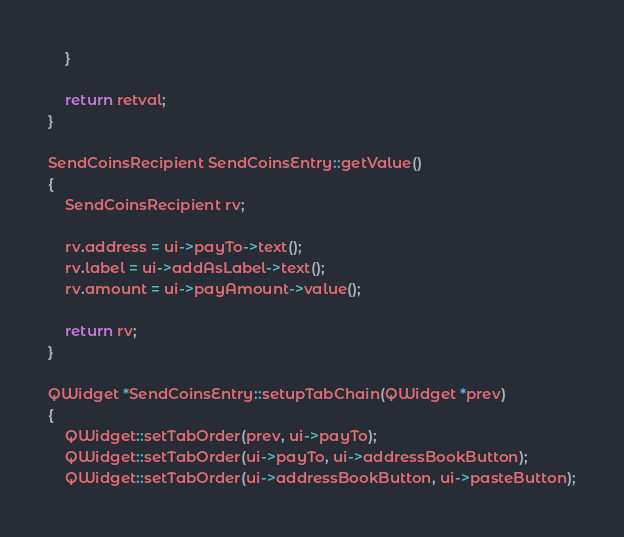Convert code to text. <code><loc_0><loc_0><loc_500><loc_500><_C++_>    }

    return retval;
}

SendCoinsRecipient SendCoinsEntry::getValue()
{
    SendCoinsRecipient rv;

    rv.address = ui->payTo->text();
    rv.label = ui->addAsLabel->text();
    rv.amount = ui->payAmount->value();

    return rv;
}

QWidget *SendCoinsEntry::setupTabChain(QWidget *prev)
{
    QWidget::setTabOrder(prev, ui->payTo);
    QWidget::setTabOrder(ui->payTo, ui->addressBookButton);
    QWidget::setTabOrder(ui->addressBookButton, ui->pasteButton);</code> 